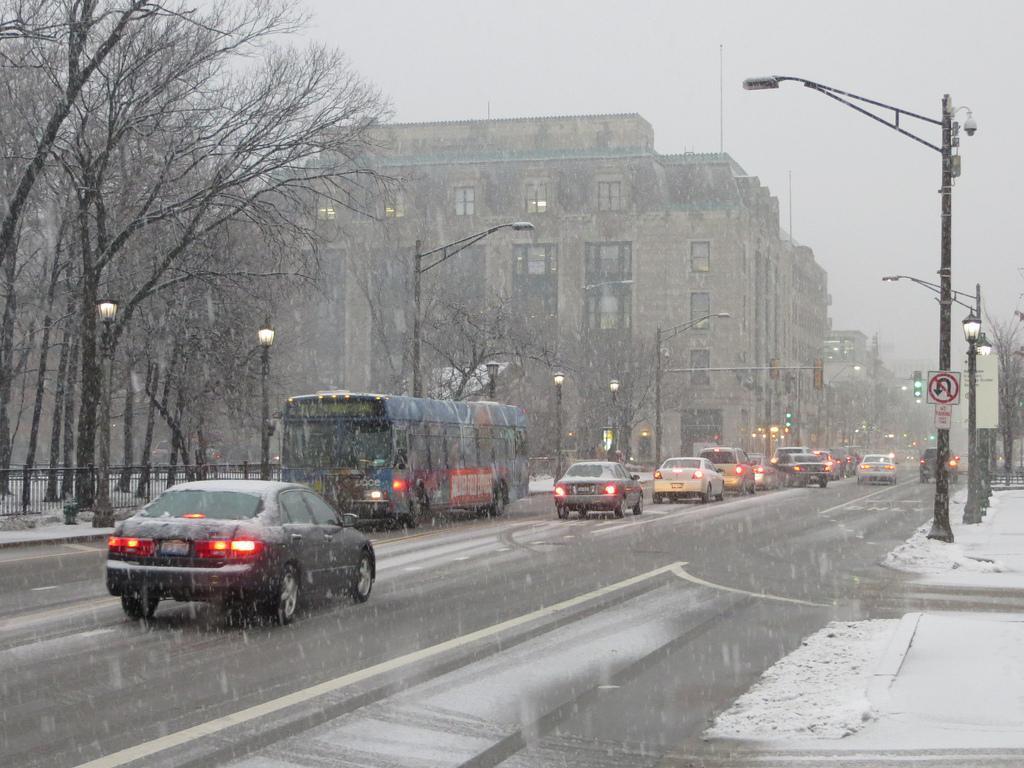How many buses are on the street?
Give a very brief answer. 1. How many buses are there?
Give a very brief answer. 1. How many green lights are there?
Give a very brief answer. 1. 